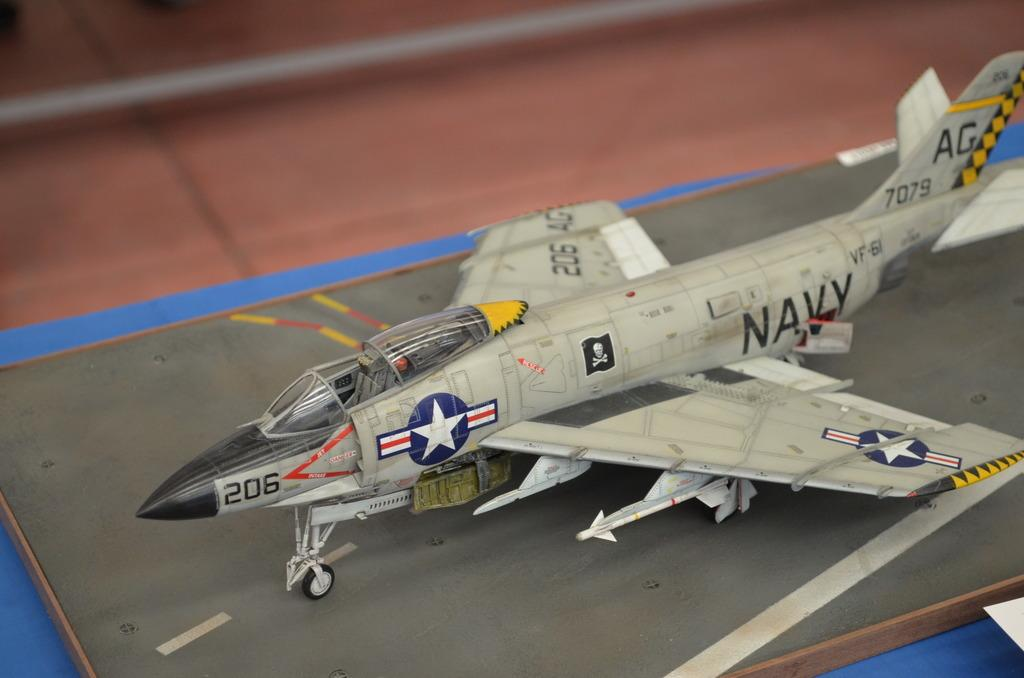<image>
Render a clear and concise summary of the photo. a model us navy airplaine sitting on the counter 